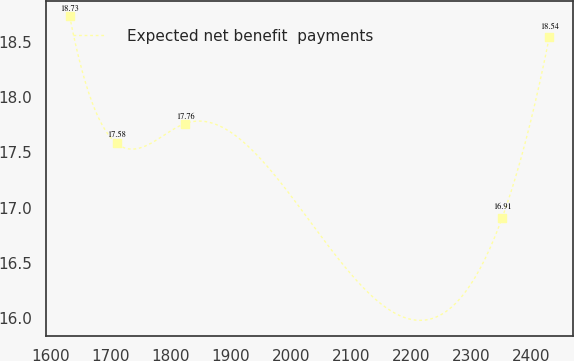<chart> <loc_0><loc_0><loc_500><loc_500><line_chart><ecel><fcel>Expected net benefit  payments<nl><fcel>1631.18<fcel>18.73<nl><fcel>1709.56<fcel>17.58<nl><fcel>1823.6<fcel>17.76<nl><fcel>2352.51<fcel>16.91<nl><fcel>2430.89<fcel>18.54<nl></chart> 